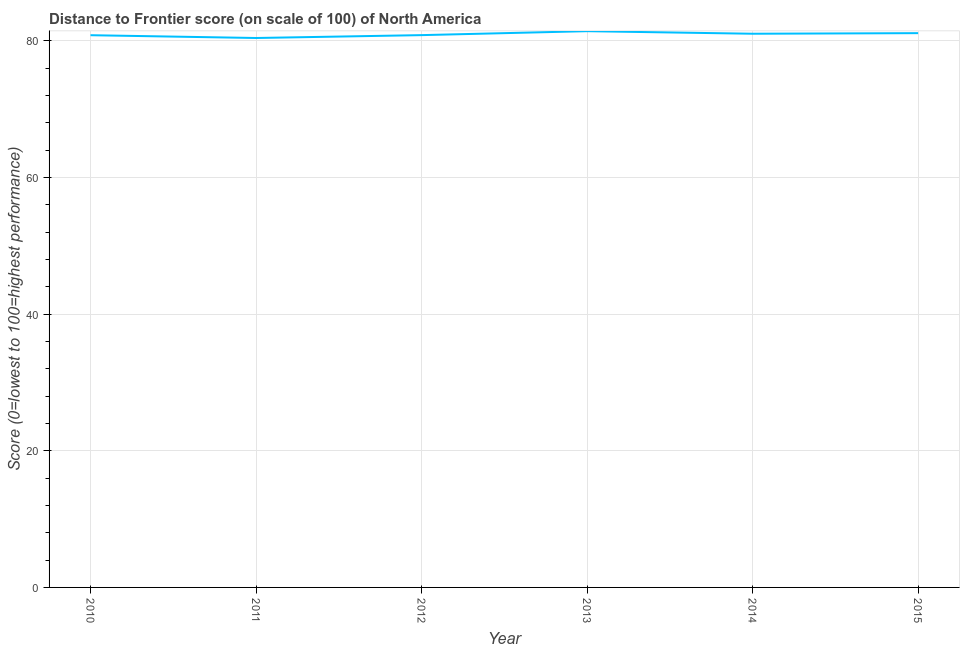What is the distance to frontier score in 2015?
Your response must be concise. 81.11. Across all years, what is the maximum distance to frontier score?
Offer a terse response. 81.4. Across all years, what is the minimum distance to frontier score?
Provide a succinct answer. 80.4. In which year was the distance to frontier score minimum?
Your answer should be very brief. 2011. What is the sum of the distance to frontier score?
Keep it short and to the point. 485.57. What is the difference between the distance to frontier score in 2010 and 2012?
Your response must be concise. -0.01. What is the average distance to frontier score per year?
Your answer should be compact. 80.93. What is the median distance to frontier score?
Ensure brevity in your answer.  80.92. What is the ratio of the distance to frontier score in 2013 to that in 2015?
Make the answer very short. 1. Is the distance to frontier score in 2011 less than that in 2013?
Your answer should be very brief. Yes. What is the difference between the highest and the second highest distance to frontier score?
Keep it short and to the point. 0.29. In how many years, is the distance to frontier score greater than the average distance to frontier score taken over all years?
Your answer should be very brief. 3. How many lines are there?
Keep it short and to the point. 1. How many years are there in the graph?
Your response must be concise. 6. Are the values on the major ticks of Y-axis written in scientific E-notation?
Provide a short and direct response. No. Does the graph contain any zero values?
Offer a very short reply. No. What is the title of the graph?
Offer a terse response. Distance to Frontier score (on scale of 100) of North America. What is the label or title of the Y-axis?
Your answer should be very brief. Score (0=lowest to 100=highest performance). What is the Score (0=lowest to 100=highest performance) of 2010?
Keep it short and to the point. 80.81. What is the Score (0=lowest to 100=highest performance) of 2011?
Keep it short and to the point. 80.4. What is the Score (0=lowest to 100=highest performance) of 2012?
Keep it short and to the point. 80.82. What is the Score (0=lowest to 100=highest performance) of 2013?
Give a very brief answer. 81.4. What is the Score (0=lowest to 100=highest performance) of 2014?
Your answer should be very brief. 81.03. What is the Score (0=lowest to 100=highest performance) in 2015?
Offer a very short reply. 81.11. What is the difference between the Score (0=lowest to 100=highest performance) in 2010 and 2011?
Provide a short and direct response. 0.41. What is the difference between the Score (0=lowest to 100=highest performance) in 2010 and 2012?
Your response must be concise. -0.01. What is the difference between the Score (0=lowest to 100=highest performance) in 2010 and 2013?
Keep it short and to the point. -0.59. What is the difference between the Score (0=lowest to 100=highest performance) in 2010 and 2014?
Give a very brief answer. -0.21. What is the difference between the Score (0=lowest to 100=highest performance) in 2010 and 2015?
Offer a very short reply. -0.3. What is the difference between the Score (0=lowest to 100=highest performance) in 2011 and 2012?
Keep it short and to the point. -0.42. What is the difference between the Score (0=lowest to 100=highest performance) in 2011 and 2013?
Your answer should be very brief. -1. What is the difference between the Score (0=lowest to 100=highest performance) in 2011 and 2014?
Provide a succinct answer. -0.62. What is the difference between the Score (0=lowest to 100=highest performance) in 2011 and 2015?
Offer a terse response. -0.71. What is the difference between the Score (0=lowest to 100=highest performance) in 2012 and 2013?
Offer a very short reply. -0.58. What is the difference between the Score (0=lowest to 100=highest performance) in 2012 and 2014?
Provide a succinct answer. -0.2. What is the difference between the Score (0=lowest to 100=highest performance) in 2012 and 2015?
Provide a short and direct response. -0.29. What is the difference between the Score (0=lowest to 100=highest performance) in 2013 and 2014?
Ensure brevity in your answer.  0.38. What is the difference between the Score (0=lowest to 100=highest performance) in 2013 and 2015?
Offer a very short reply. 0.29. What is the difference between the Score (0=lowest to 100=highest performance) in 2014 and 2015?
Keep it short and to the point. -0.09. What is the ratio of the Score (0=lowest to 100=highest performance) in 2010 to that in 2012?
Your answer should be compact. 1. What is the ratio of the Score (0=lowest to 100=highest performance) in 2010 to that in 2013?
Your answer should be very brief. 0.99. What is the ratio of the Score (0=lowest to 100=highest performance) in 2010 to that in 2014?
Provide a short and direct response. 1. What is the ratio of the Score (0=lowest to 100=highest performance) in 2010 to that in 2015?
Your answer should be compact. 1. What is the ratio of the Score (0=lowest to 100=highest performance) in 2011 to that in 2013?
Provide a succinct answer. 0.99. What is the ratio of the Score (0=lowest to 100=highest performance) in 2011 to that in 2014?
Make the answer very short. 0.99. What is the ratio of the Score (0=lowest to 100=highest performance) in 2012 to that in 2013?
Your answer should be compact. 0.99. What is the ratio of the Score (0=lowest to 100=highest performance) in 2013 to that in 2014?
Give a very brief answer. 1. What is the ratio of the Score (0=lowest to 100=highest performance) in 2013 to that in 2015?
Your answer should be very brief. 1. What is the ratio of the Score (0=lowest to 100=highest performance) in 2014 to that in 2015?
Make the answer very short. 1. 